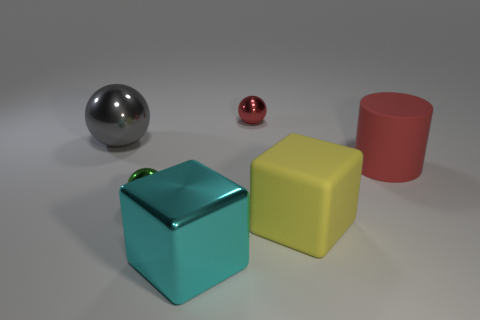Do the block right of the large metallic cube and the rubber thing behind the large rubber cube have the same size?
Your response must be concise. Yes. How many green spheres are there?
Your answer should be compact. 1. How big is the cube that is in front of the large cube that is right of the large metallic object that is right of the big gray sphere?
Your answer should be compact. Large. Does the big rubber cylinder have the same color as the large shiny cube?
Offer a very short reply. No. Is there anything else that has the same size as the yellow thing?
Offer a very short reply. Yes. How many spheres are behind the red cylinder?
Your answer should be compact. 2. Is the number of gray objects behind the large cyan cube the same as the number of matte cubes?
Offer a terse response. Yes. What number of things are either small shiny cylinders or tiny red spheres?
Provide a short and direct response. 1. Are there any other things that have the same shape as the large cyan thing?
Provide a succinct answer. Yes. The red object that is in front of the shiny thing behind the big gray metal ball is what shape?
Give a very brief answer. Cylinder. 